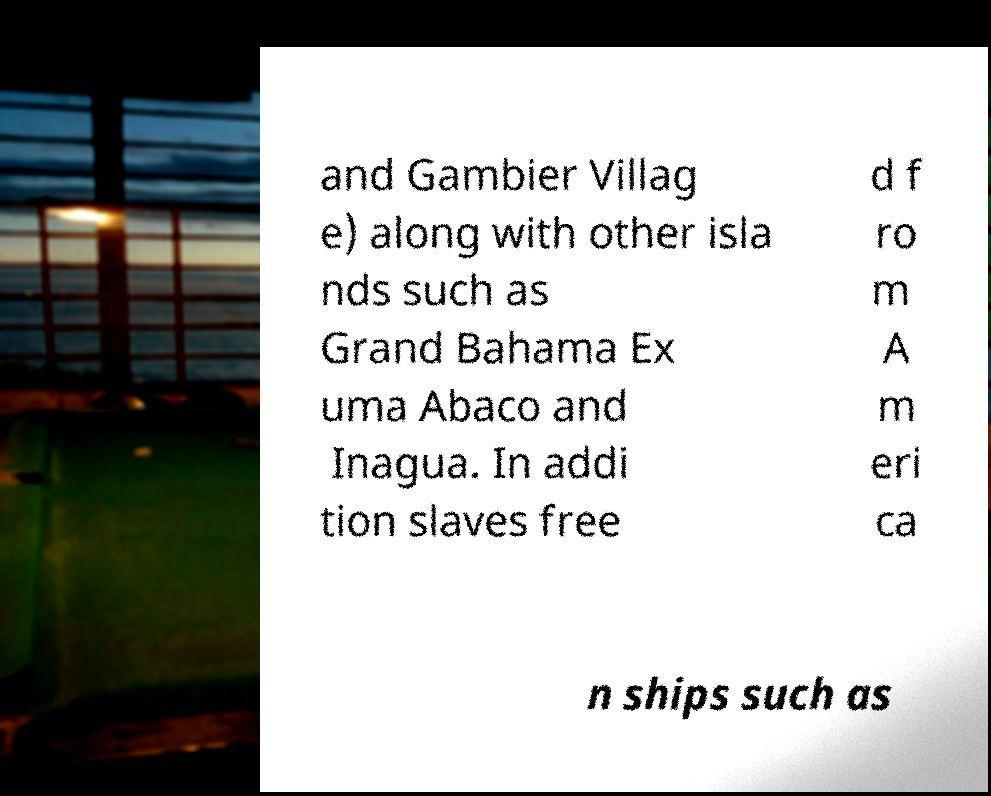I need the written content from this picture converted into text. Can you do that? and Gambier Villag e) along with other isla nds such as Grand Bahama Ex uma Abaco and Inagua. In addi tion slaves free d f ro m A m eri ca n ships such as 